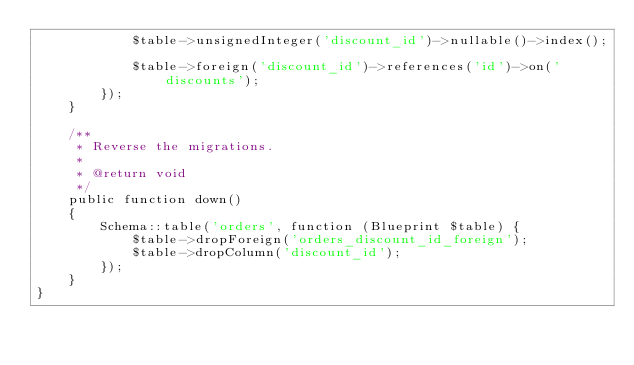Convert code to text. <code><loc_0><loc_0><loc_500><loc_500><_PHP_>            $table->unsignedInteger('discount_id')->nullable()->index();
            
            $table->foreign('discount_id')->references('id')->on('discounts');
        });
    }

    /**
     * Reverse the migrations.
     *
     * @return void
     */
    public function down()
    {
        Schema::table('orders', function (Blueprint $table) {
            $table->dropForeign('orders_discount_id_foreign');
            $table->dropColumn('discount_id');
        });
    }
}
</code> 